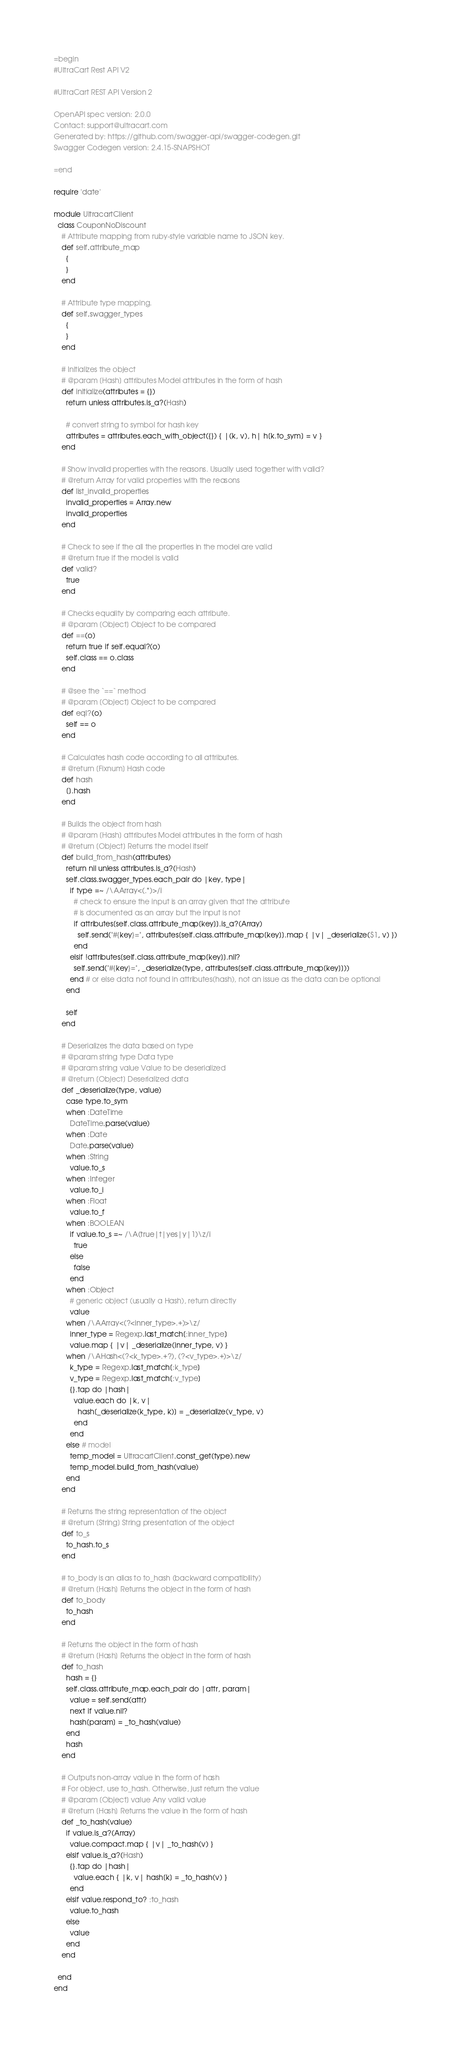Convert code to text. <code><loc_0><loc_0><loc_500><loc_500><_Ruby_>=begin
#UltraCart Rest API V2

#UltraCart REST API Version 2

OpenAPI spec version: 2.0.0
Contact: support@ultracart.com
Generated by: https://github.com/swagger-api/swagger-codegen.git
Swagger Codegen version: 2.4.15-SNAPSHOT

=end

require 'date'

module UltracartClient
  class CouponNoDiscount
    # Attribute mapping from ruby-style variable name to JSON key.
    def self.attribute_map
      {
      }
    end

    # Attribute type mapping.
    def self.swagger_types
      {
      }
    end

    # Initializes the object
    # @param [Hash] attributes Model attributes in the form of hash
    def initialize(attributes = {})
      return unless attributes.is_a?(Hash)

      # convert string to symbol for hash key
      attributes = attributes.each_with_object({}) { |(k, v), h| h[k.to_sym] = v }
    end

    # Show invalid properties with the reasons. Usually used together with valid?
    # @return Array for valid properties with the reasons
    def list_invalid_properties
      invalid_properties = Array.new
      invalid_properties
    end

    # Check to see if the all the properties in the model are valid
    # @return true if the model is valid
    def valid?
      true
    end

    # Checks equality by comparing each attribute.
    # @param [Object] Object to be compared
    def ==(o)
      return true if self.equal?(o)
      self.class == o.class
    end

    # @see the `==` method
    # @param [Object] Object to be compared
    def eql?(o)
      self == o
    end

    # Calculates hash code according to all attributes.
    # @return [Fixnum] Hash code
    def hash
      [].hash
    end

    # Builds the object from hash
    # @param [Hash] attributes Model attributes in the form of hash
    # @return [Object] Returns the model itself
    def build_from_hash(attributes)
      return nil unless attributes.is_a?(Hash)
      self.class.swagger_types.each_pair do |key, type|
        if type =~ /\AArray<(.*)>/i
          # check to ensure the input is an array given that the attribute
          # is documented as an array but the input is not
          if attributes[self.class.attribute_map[key]].is_a?(Array)
            self.send("#{key}=", attributes[self.class.attribute_map[key]].map { |v| _deserialize($1, v) })
          end
        elsif !attributes[self.class.attribute_map[key]].nil?
          self.send("#{key}=", _deserialize(type, attributes[self.class.attribute_map[key]]))
        end # or else data not found in attributes(hash), not an issue as the data can be optional
      end

      self
    end

    # Deserializes the data based on type
    # @param string type Data type
    # @param string value Value to be deserialized
    # @return [Object] Deserialized data
    def _deserialize(type, value)
      case type.to_sym
      when :DateTime
        DateTime.parse(value)
      when :Date
        Date.parse(value)
      when :String
        value.to_s
      when :Integer
        value.to_i
      when :Float
        value.to_f
      when :BOOLEAN
        if value.to_s =~ /\A(true|t|yes|y|1)\z/i
          true
        else
          false
        end
      when :Object
        # generic object (usually a Hash), return directly
        value
      when /\AArray<(?<inner_type>.+)>\z/
        inner_type = Regexp.last_match[:inner_type]
        value.map { |v| _deserialize(inner_type, v) }
      when /\AHash<(?<k_type>.+?), (?<v_type>.+)>\z/
        k_type = Regexp.last_match[:k_type]
        v_type = Regexp.last_match[:v_type]
        {}.tap do |hash|
          value.each do |k, v|
            hash[_deserialize(k_type, k)] = _deserialize(v_type, v)
          end
        end
      else # model
        temp_model = UltracartClient.const_get(type).new
        temp_model.build_from_hash(value)
      end
    end

    # Returns the string representation of the object
    # @return [String] String presentation of the object
    def to_s
      to_hash.to_s
    end

    # to_body is an alias to to_hash (backward compatibility)
    # @return [Hash] Returns the object in the form of hash
    def to_body
      to_hash
    end

    # Returns the object in the form of hash
    # @return [Hash] Returns the object in the form of hash
    def to_hash
      hash = {}
      self.class.attribute_map.each_pair do |attr, param|
        value = self.send(attr)
        next if value.nil?
        hash[param] = _to_hash(value)
      end
      hash
    end

    # Outputs non-array value in the form of hash
    # For object, use to_hash. Otherwise, just return the value
    # @param [Object] value Any valid value
    # @return [Hash] Returns the value in the form of hash
    def _to_hash(value)
      if value.is_a?(Array)
        value.compact.map { |v| _to_hash(v) }
      elsif value.is_a?(Hash)
        {}.tap do |hash|
          value.each { |k, v| hash[k] = _to_hash(v) }
        end
      elsif value.respond_to? :to_hash
        value.to_hash
      else
        value
      end
    end

  end
end
</code> 